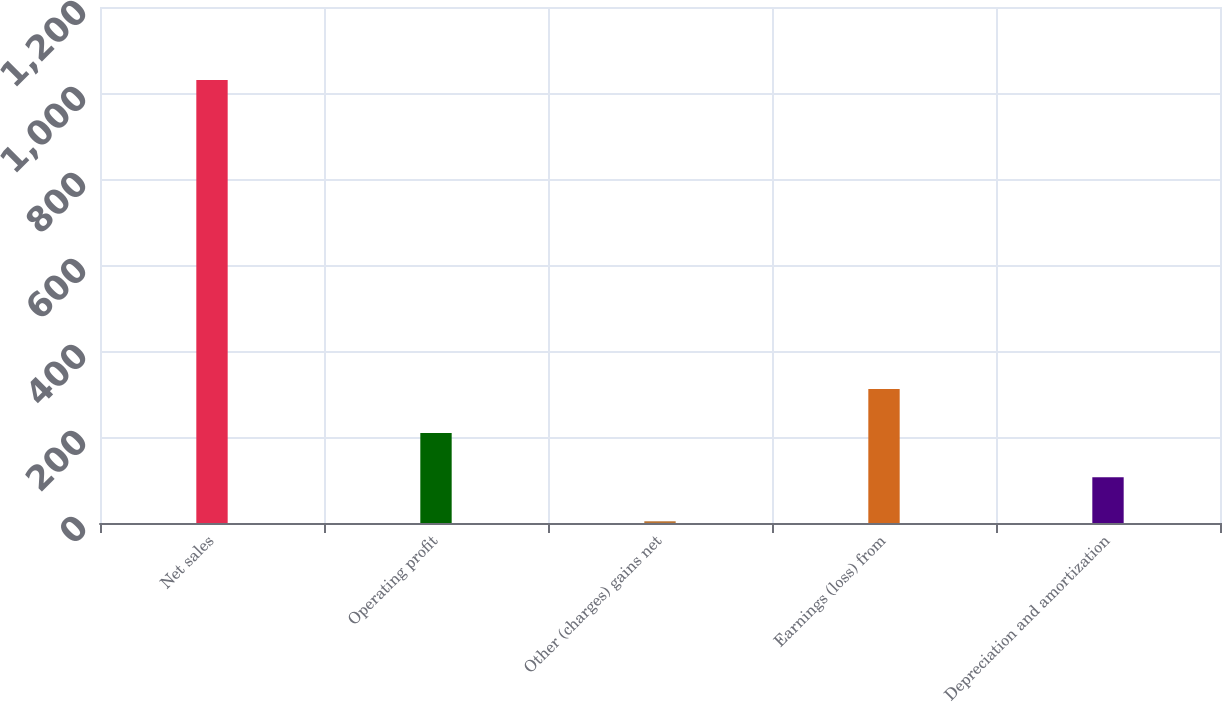Convert chart to OTSL. <chart><loc_0><loc_0><loc_500><loc_500><bar_chart><fcel>Net sales<fcel>Operating profit<fcel>Other (charges) gains net<fcel>Earnings (loss) from<fcel>Depreciation and amortization<nl><fcel>1030<fcel>209.2<fcel>4<fcel>311.8<fcel>106.6<nl></chart> 